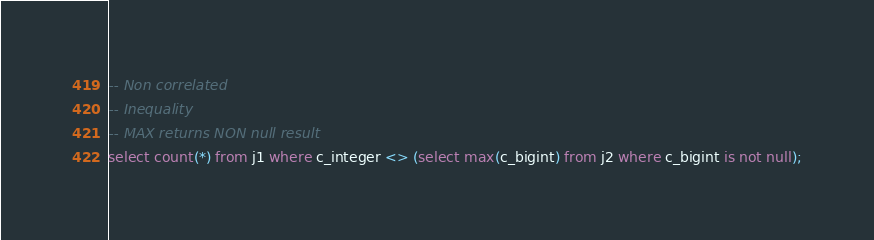<code> <loc_0><loc_0><loc_500><loc_500><_SQL_>-- Non correlated
-- Inequality
-- MAX returns NON null result
select count(*) from j1 where c_integer <> (select max(c_bigint) from j2 where c_bigint is not null);
</code> 